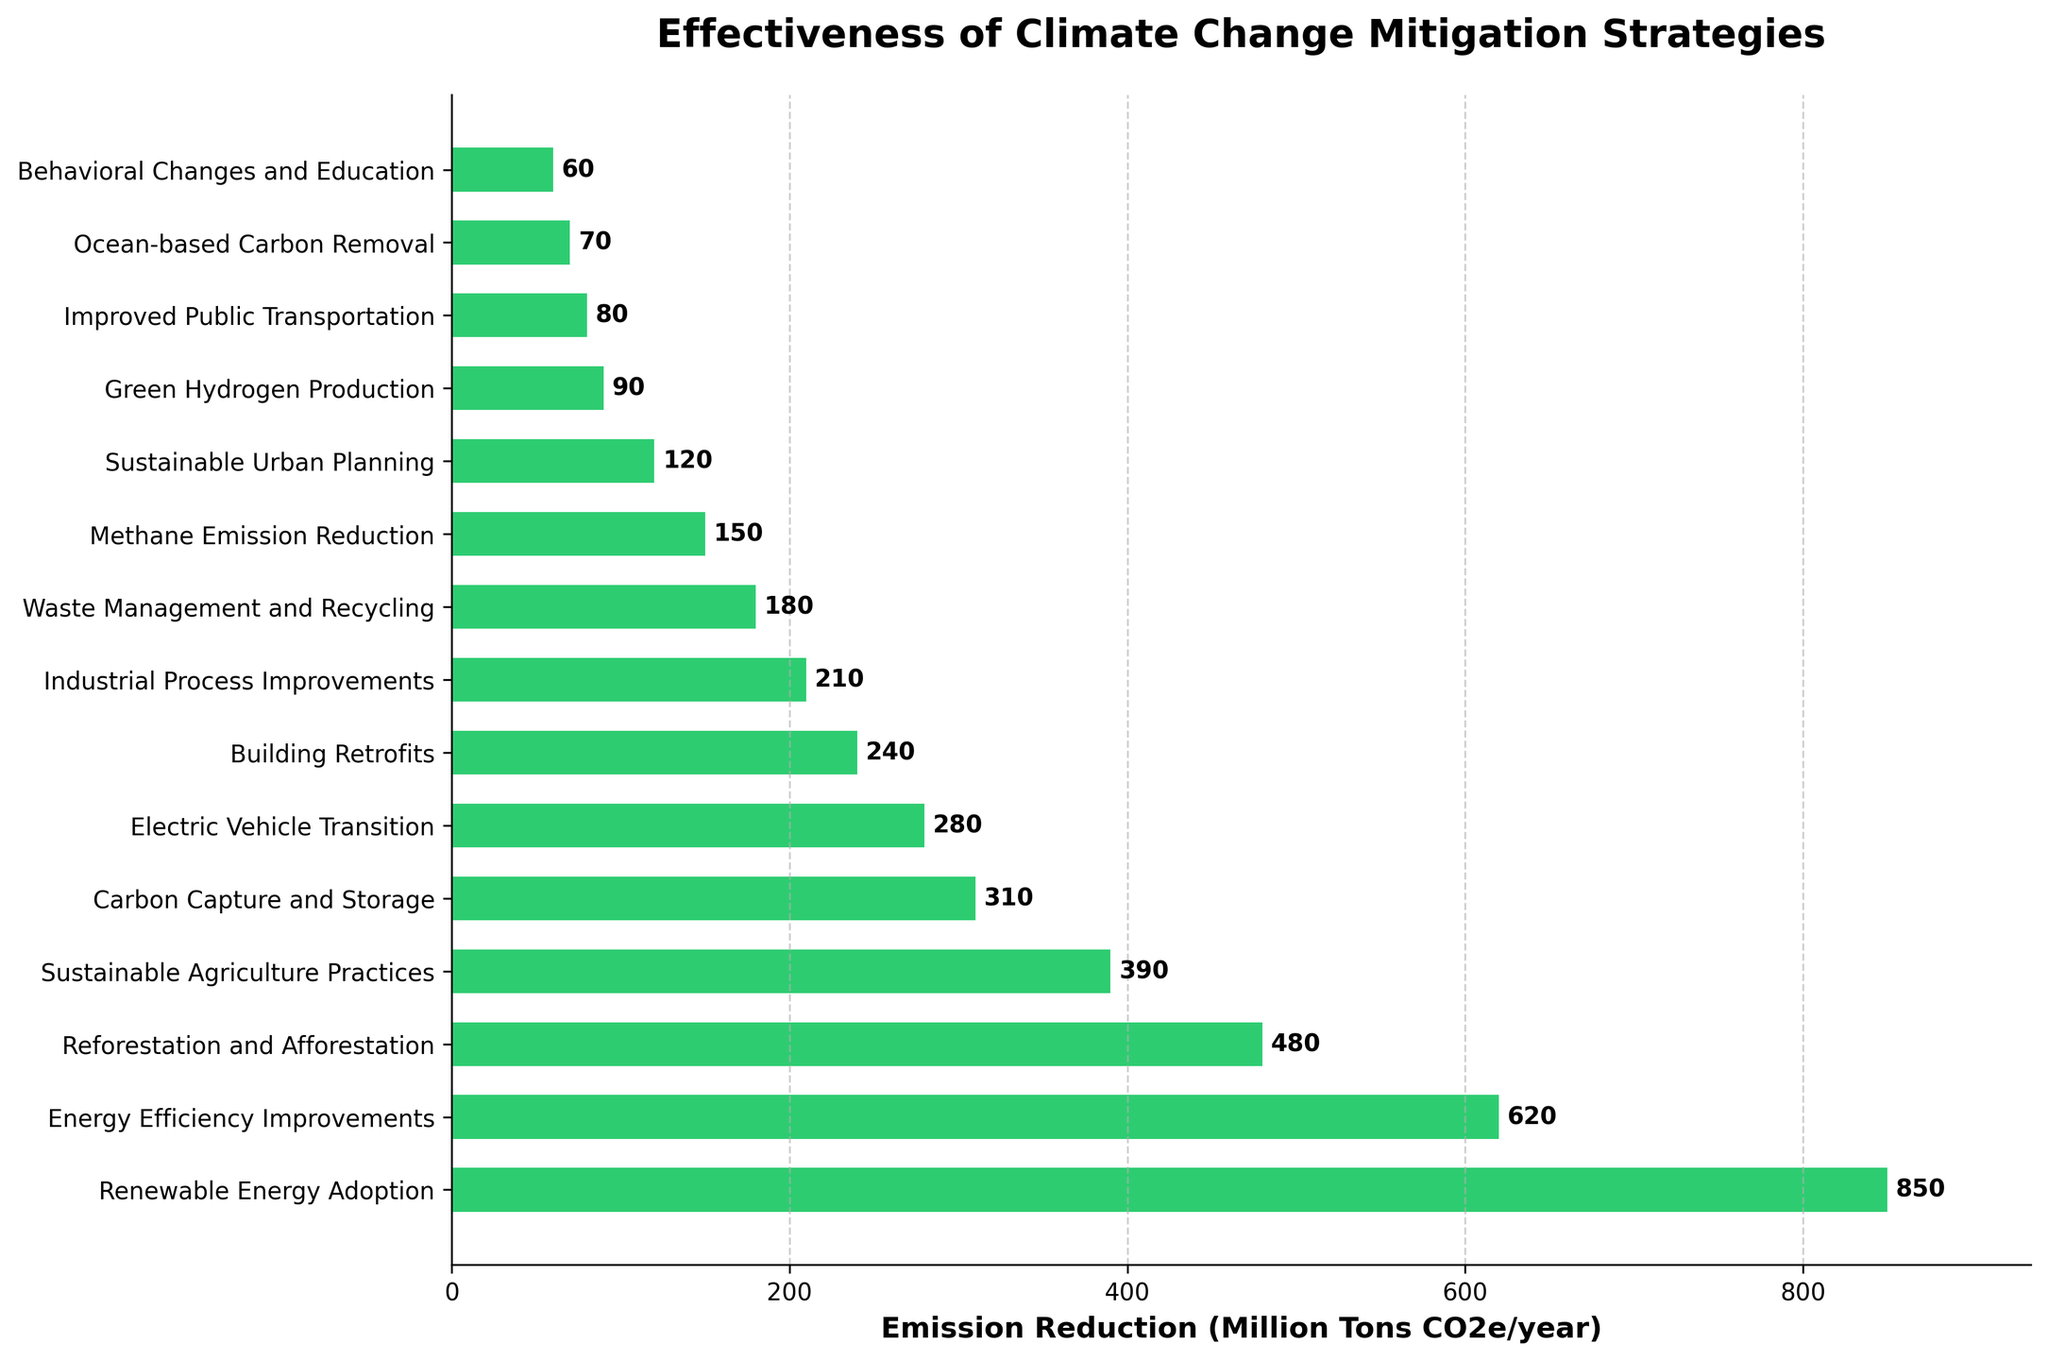Which strategy is most effective in reducing greenhouse gas emissions? The bar representing the "Renewable Energy Adoption" strategy extends furthest to the right, indicating it has the highest emission reduction.
Answer: Renewable Energy Adoption Which strategy has the lowest emission reduction? The shortest bar corresponds to the "Behavioral Changes and Education" strategy, indicating it has the lowest emission reduction.
Answer: Behavioral Changes and Education What is the combined emission reduction of the top three strategies? The top three strategies are "Renewable Energy Adoption" (850), "Energy Efficiency Improvements" (620), and "Reforestation and Afforestation" (480). Adding these values: 850 + 620 + 480 = 1950.
Answer: 1950 How much more effective is "Renewable Energy Adoption" compared to "Electric Vehicle Transition"? The emission reduction for "Renewable Energy Adoption" is 850, and for "Electric Vehicle Transition" is 280. The difference is 850 - 280 = 570.
Answer: 570 Which strategies have an emission reduction greater than 300 million tons CO2e/year? The bars with lengths indicating more than 300 million tons reduction are "Renewable Energy Adoption" (850), "Energy Efficiency Improvements" (620), "Reforestation and Afforestation" (480), "Sustainable Agriculture Practices" (390), and "Carbon Capture and Storage" (310).
Answer: Renewable Energy Adoption, Energy Efficiency Improvements, Reforestation and Afforestation, Sustainable Agriculture Practices, Carbon Capture and Storage What is the difference in emission reduction between "Building Retrofits" and "Industrial Process Improvements"? The emission reduction for "Building Retrofits" is 240, and for "Industrial Process Improvements" is 210. The difference is 240 - 210 = 30.
Answer: 30 Among "Waste Management and Recycling" and "Methane Emission Reduction," which strategy is more effective, and by how much? The bar for "Waste Management and Recycling" (180) is longer than that for "Methane Emission Reduction" (150). The difference is 180 - 150 = 30.
Answer: Waste Management and Recycling, 30 What is the average emission reduction of all the strategies listed? Sum all the emission reductions: 850 + 620 + 480 + 390 + 310 + 280 + 240 + 210 + 180 + 150 + 120 + 90 + 80 + 70 + 60 = 4130. There are 15 strategies, so the average is 4130 / 15 ≈ 275.33.
Answer: 275.33 Which strategy falls closest to the median in terms of emission reduction? Listed in order: 60, 70, 80, 90, 120, 150, 180, 210, 240, 280, 310, 390, 480, 620, 850. The middle (median) value in this list is 210 for "Industrial Process Improvements."
Answer: Industrial Process Improvements 